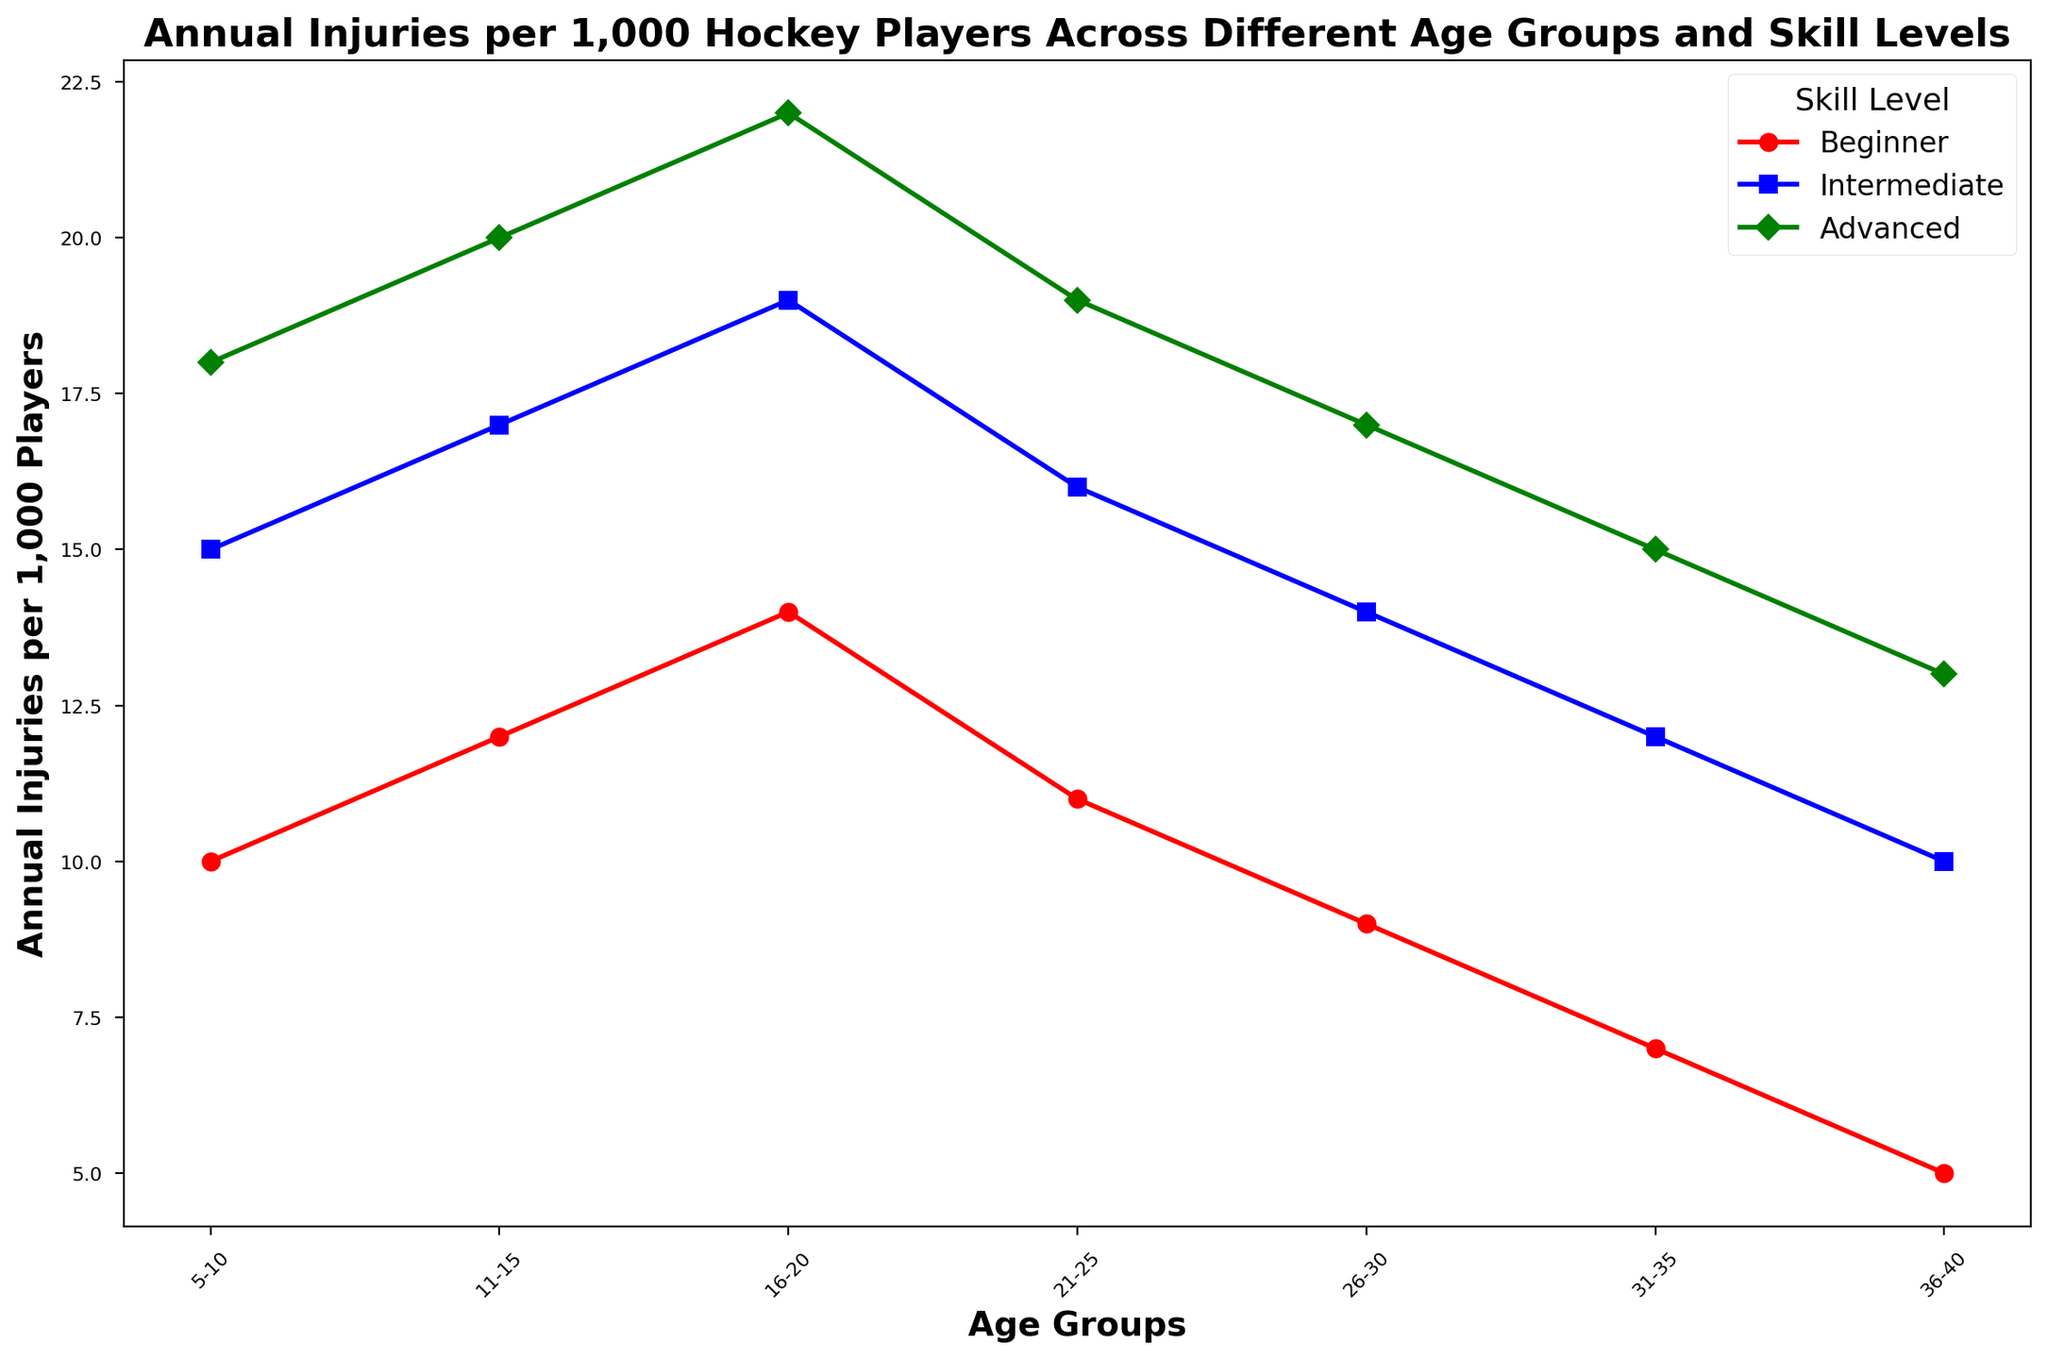What's the trend in annual injuries per 1,000 players for advanced skill level as age increases? Looking at the green line which represents the advanced skill level, we see that the number of annual injuries per 1,000 players increases consistently as age increases from 5-10 to 16-20, peaks at 16-20, then decreases from 21-25 onwards.
Answer: Increases then decreases Which age group has the highest number of injuries for intermediate players? By comparing the peaks of the blue line representing intermediate players, we see that the highest point is at the 16-20 age group.
Answer: 16-20 How does the number of injuries in the 26-30 age group for beginner players compare to the 36-40 age group for intermediate players? For beginner players in the 26-30 age group, the number of injuries is 9. For intermediate players in the 36-40 age group, the number is 10. Therefore, beginner players aged 26-30 have fewer injuries than intermediate players aged 36-40.
Answer: Fewer What is the average number of annual injuries per 1,000 players for advanced players across all age groups? The values for advanced players are 18, 20, 22, 19, 17, 15, and 13. Summing these values gives 124. Dividing by the number of age groups (7) yields an average of 124/7 = 17.71.
Answer: 17.71 By how many injuries does the peak number of injuries in intermediate players exceed the number of injuries in 11-15 age group advanced players? The peak number of injuries for intermediate players is 19 (at 16-20 age group) and the number of injuries for advanced players at 11-15 age group is 20. The first value exceeds the second by 19 - 20 = -1. Therefore, the peak for intermediate is less than the number of 11-15 advanced players by 1 injury.
Answer: 1 fewer Which age group and skill level combination has the lowest number of injuries? By scanning the chart for the lowest points on the lines, the lowest point is the red line for beginner players at the 36-40 age group, with a value of 5 injuries per 1,000 players.
Answer: 36-40 Beginner How many more injuries are there in the 5-10 age group for advanced players than for beginner players? The injuries for advanced players in the 5-10 age group are 18, and for beginner players, it's 10. Therefore, the difference is 18 - 10 = 8 injuries.
Answer: 8 What visual trend is noticeable in injury patterns as you move from beginner to advanced skill levels across all age groups? Observing the red, blue, and green lines, it's evident that the number of injuries generally increases from beginner to intermediate to advanced skill levels in any given age group.
Answer: Increases What is the total number of injuries across all age groups for intermediate players? Summing the injury values for intermediate players across all age groups: 15 + 17 + 19 + 16 + 14 + 12 + 10 equals 103 injuries.
Answer: 103 